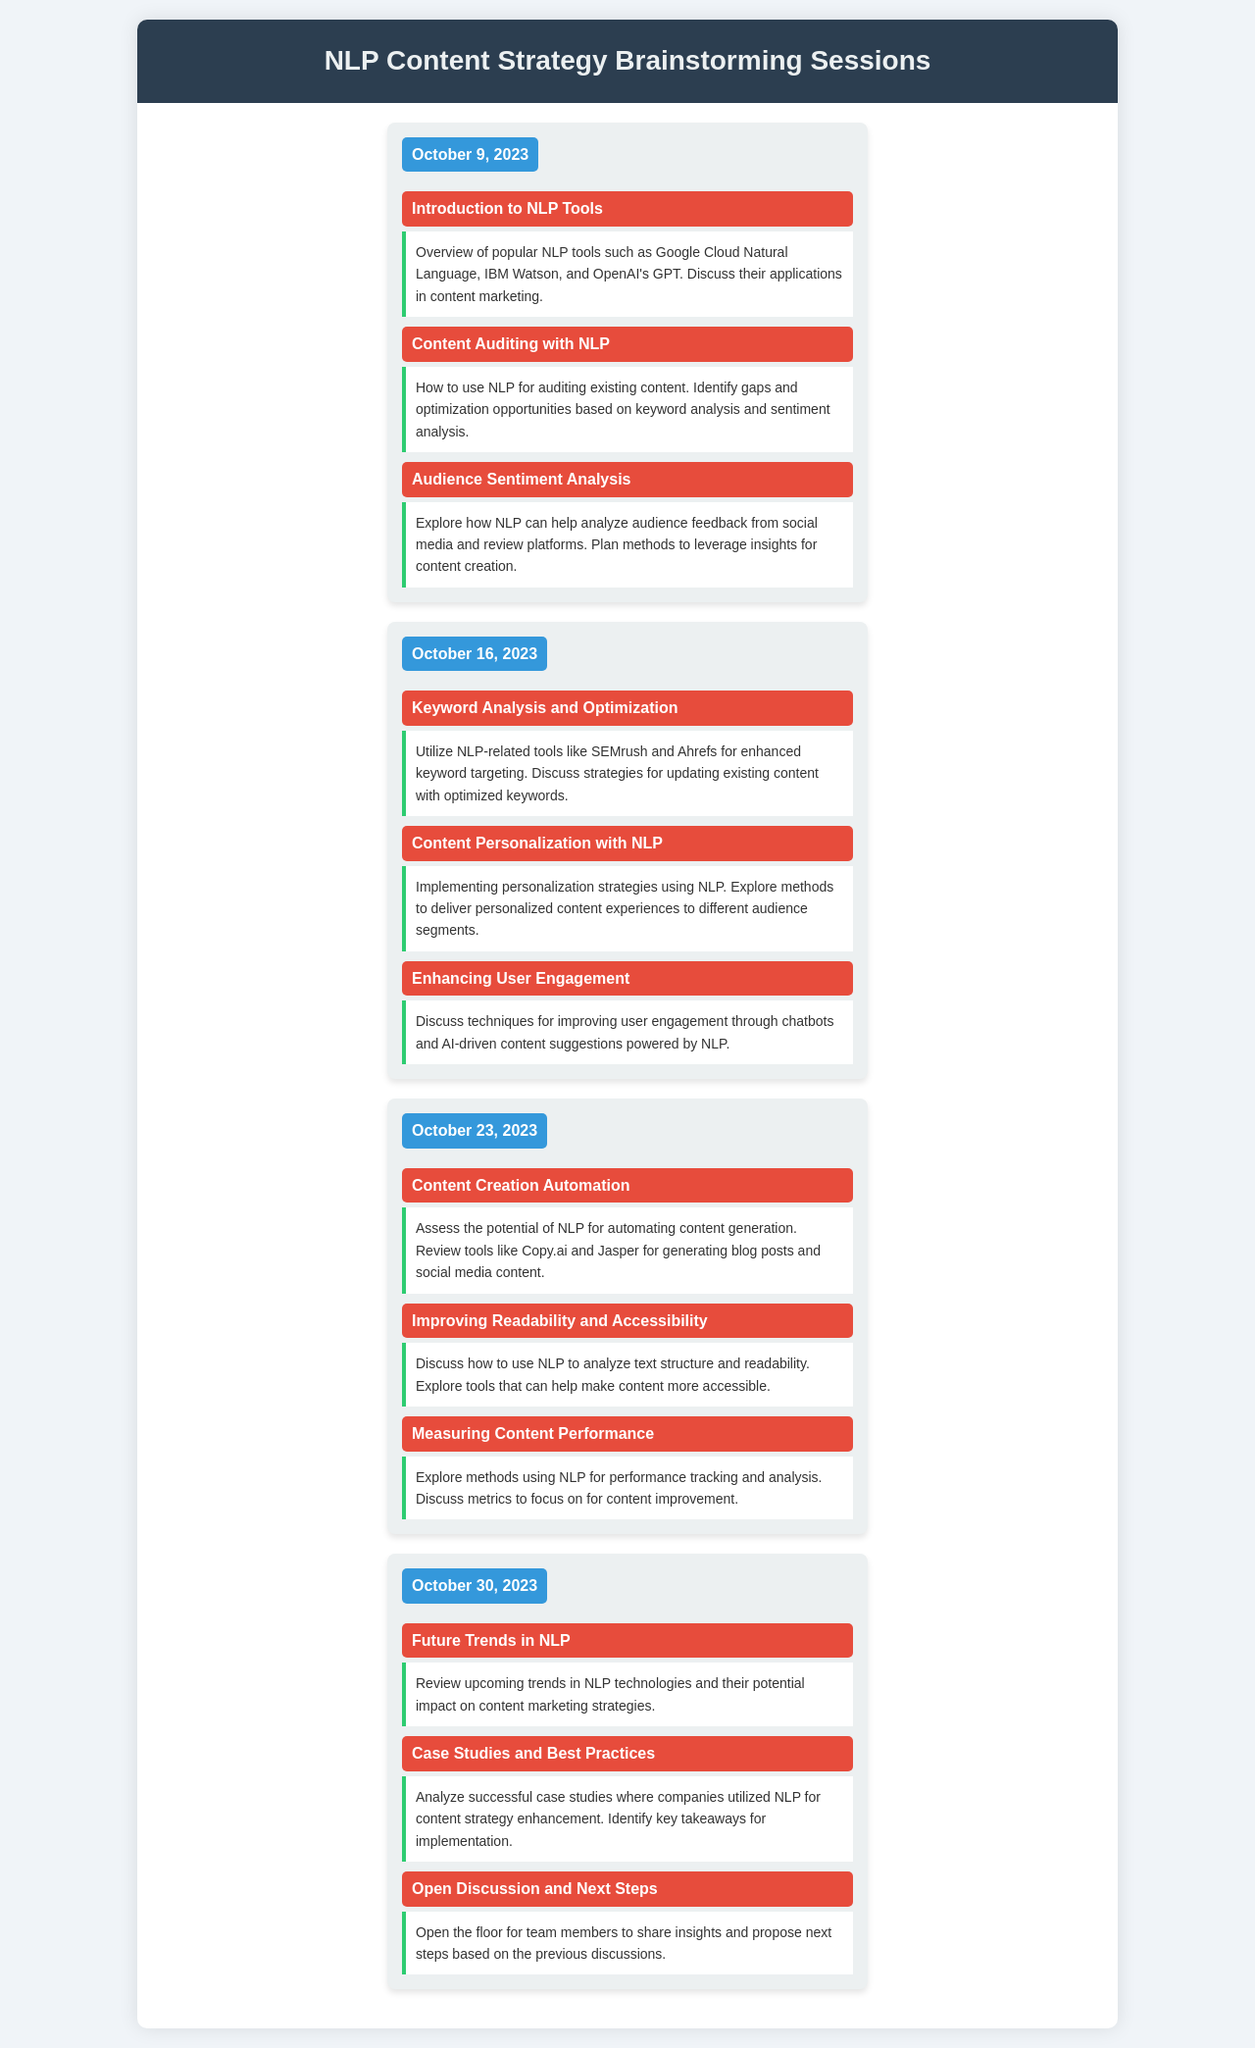What is the date of the first session? The date of the first session is mentioned at the top of the first session section.
Answer: October 9, 2023 What topic is discussed on October 16, 2023? The topic for that date is highlighted in the second session section.
Answer: Keyword Analysis and Optimization How many topics are covered on October 23, 2023? By counting the topic entries in the third session section, we can determine the number of topics discussed.
Answer: Three What is the focus of the session on October 30, 2023? The topics listed in the fourth session section indicate the main focus areas for that date.
Answer: Future Trends in NLP Which tool is reviewed for automating content generation? This information can be found in the details of the topic section under the third session.
Answer: Copy.ai What is the primary purpose of the weekly brainstorming sessions? The overall aim of the sessions can be inferred from the title and content of the document.
Answer: Content optimization How many sessions are scheduled according to the document? By counting the number of session blocks within the schedule, the total number can be identified.
Answer: Four What topic discusses improving user engagement? This can be observed as one of the detailed topics in the session on October 16, 2023.
Answer: Enhancing User Engagement What analysis method is employed for audience feedback? The method is indicated under the third topic in the first session section.
Answer: Sentiment analysis 